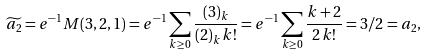Convert formula to latex. <formula><loc_0><loc_0><loc_500><loc_500>\widetilde { a _ { 2 } } = e ^ { - 1 } M ( 3 , 2 , 1 ) = e ^ { - 1 } \sum _ { k \geq 0 } \frac { ( 3 ) _ { k } } { ( 2 ) _ { k } \, k ! } = e ^ { - 1 } \sum _ { k \geq 0 } \frac { k + 2 } { 2 \, k ! } = 3 / 2 = a _ { 2 } ,</formula> 